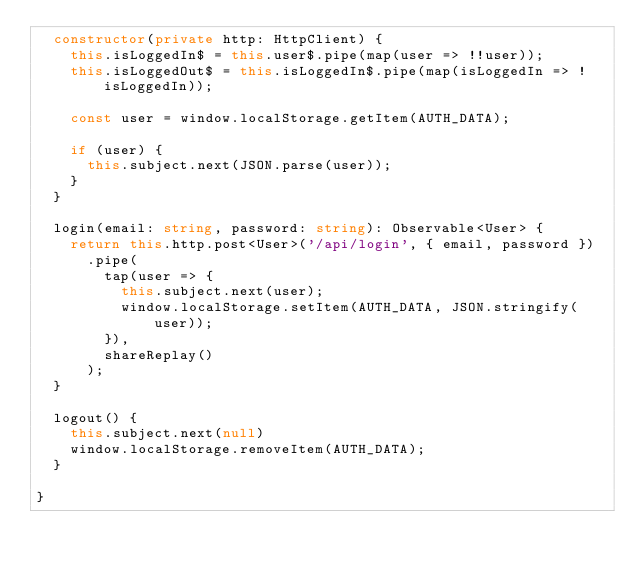<code> <loc_0><loc_0><loc_500><loc_500><_TypeScript_>  constructor(private http: HttpClient) {
    this.isLoggedIn$ = this.user$.pipe(map(user => !!user));
    this.isLoggedOut$ = this.isLoggedIn$.pipe(map(isLoggedIn => !isLoggedIn));

    const user = window.localStorage.getItem(AUTH_DATA);

    if (user) {
      this.subject.next(JSON.parse(user));
    }
  }

  login(email: string, password: string): Observable<User> {
    return this.http.post<User>('/api/login', { email, password })
      .pipe(
        tap(user => {
          this.subject.next(user);
          window.localStorage.setItem(AUTH_DATA, JSON.stringify(user));
        }),
        shareReplay()
      );
  }

  logout() {
    this.subject.next(null)
    window.localStorage.removeItem(AUTH_DATA);
  }

}
</code> 